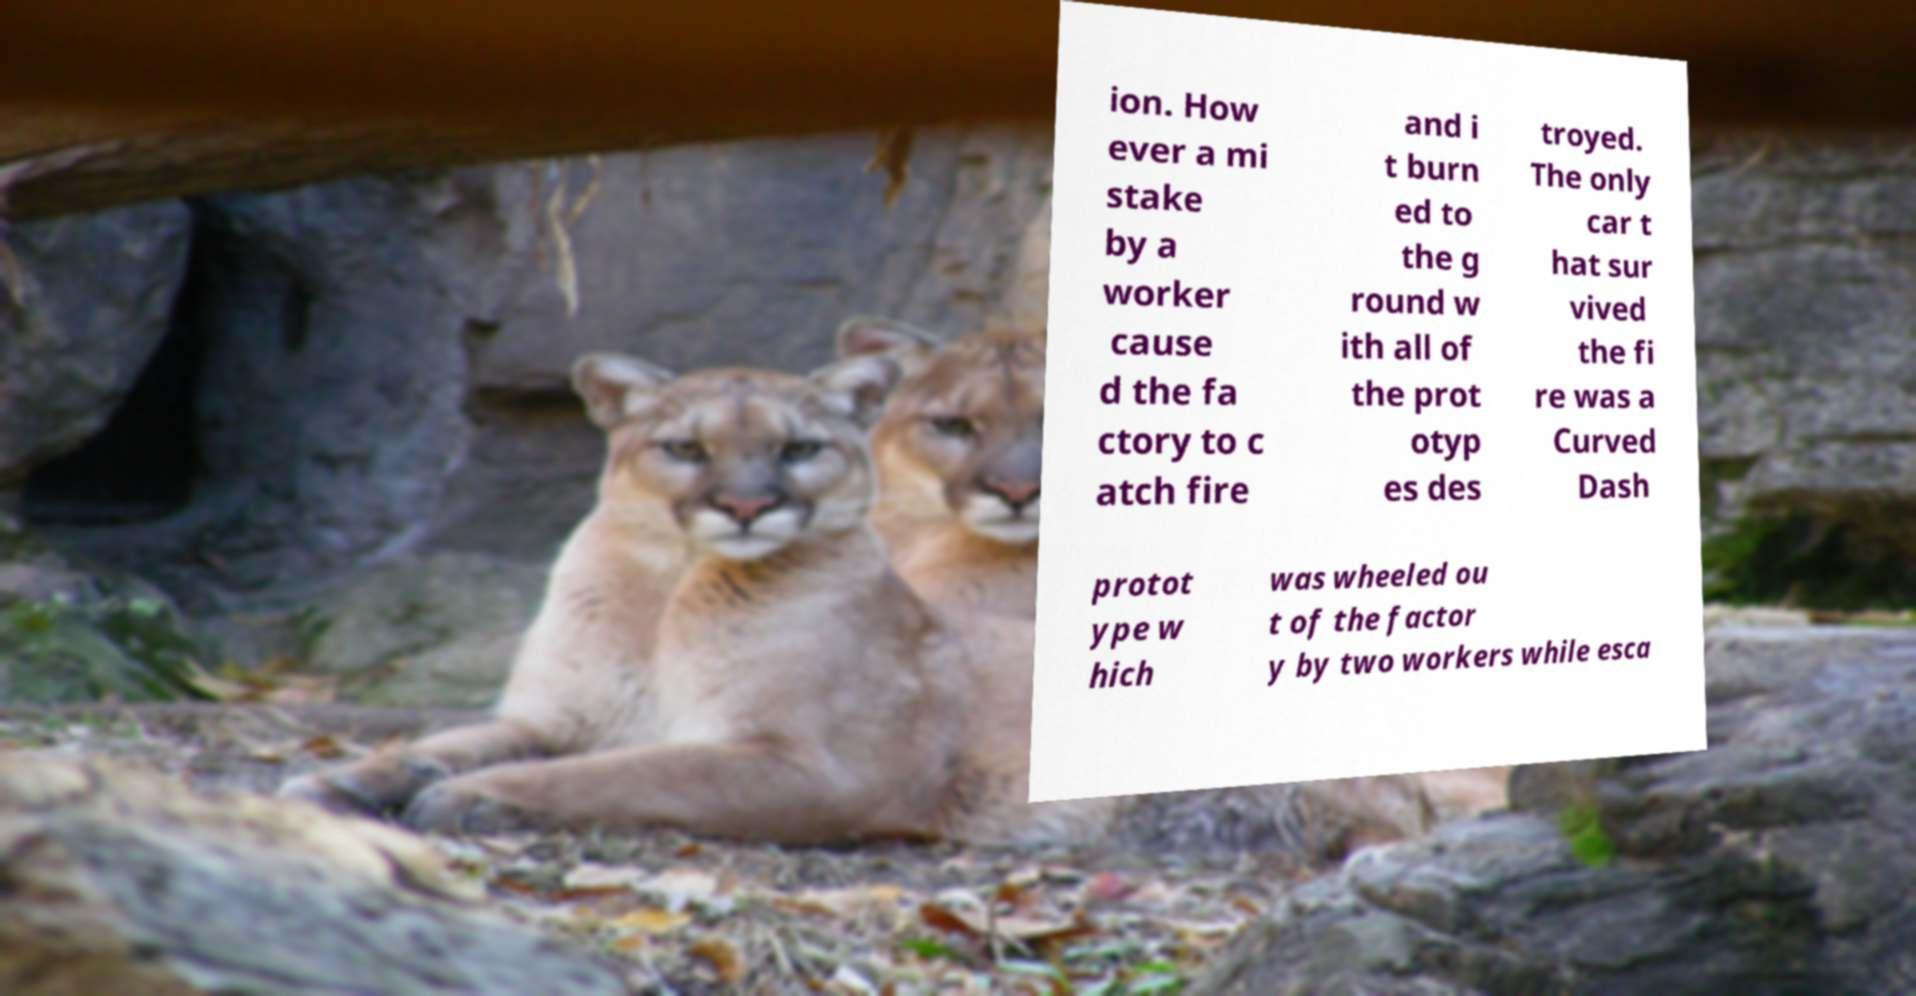Please identify and transcribe the text found in this image. ion. How ever a mi stake by a worker cause d the fa ctory to c atch fire and i t burn ed to the g round w ith all of the prot otyp es des troyed. The only car t hat sur vived the fi re was a Curved Dash protot ype w hich was wheeled ou t of the factor y by two workers while esca 